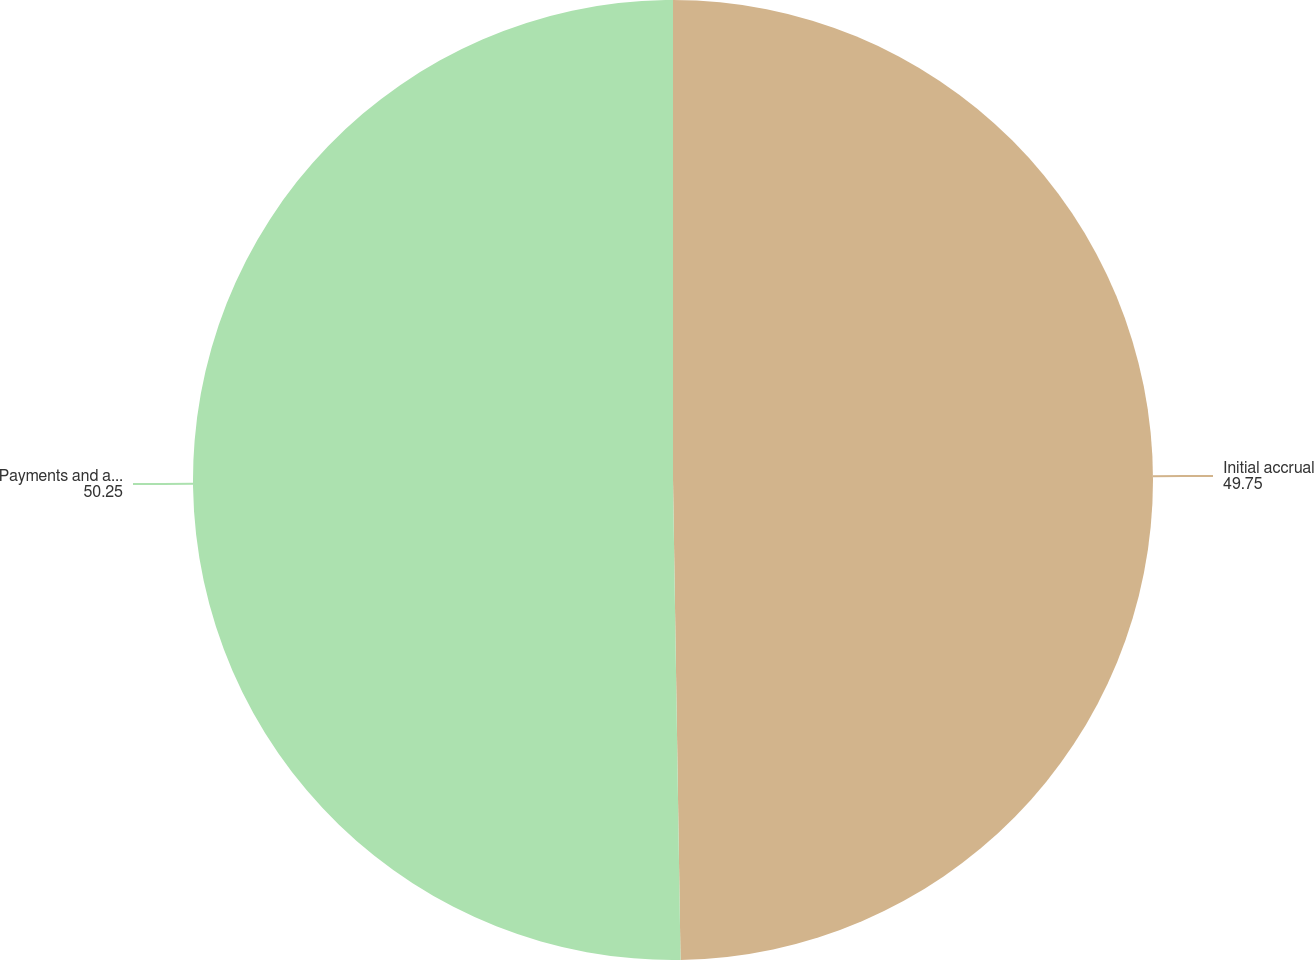Convert chart. <chart><loc_0><loc_0><loc_500><loc_500><pie_chart><fcel>Initial accrual<fcel>Payments and adjustments<nl><fcel>49.75%<fcel>50.25%<nl></chart> 